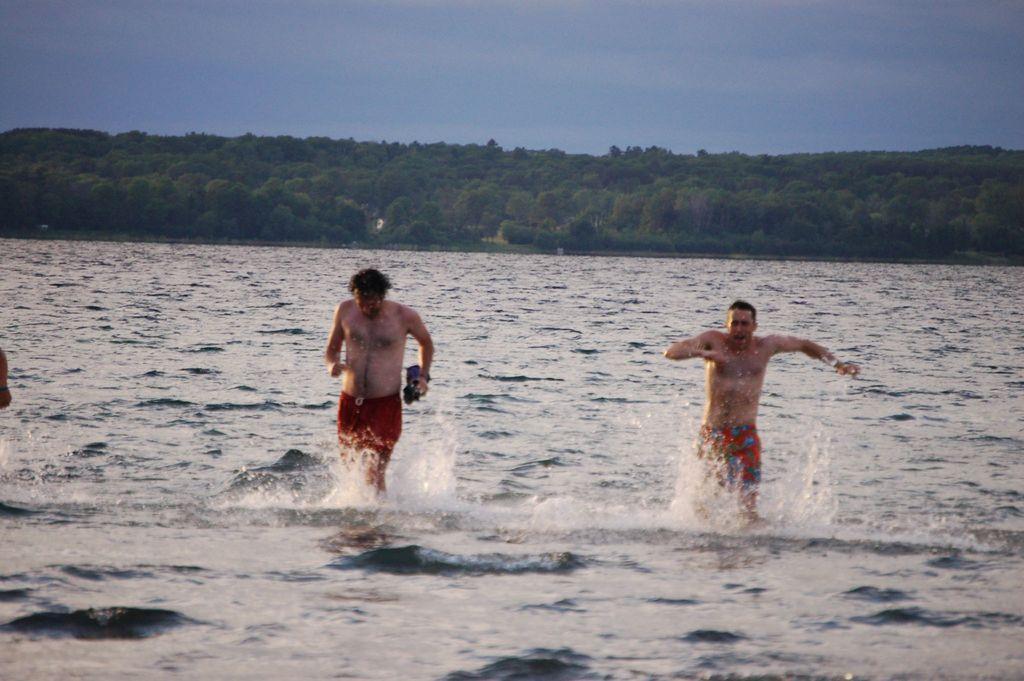Could you give a brief overview of what you see in this image? In this picture I can see two persons, there is water, there are trees, and in the background there is the sky. 